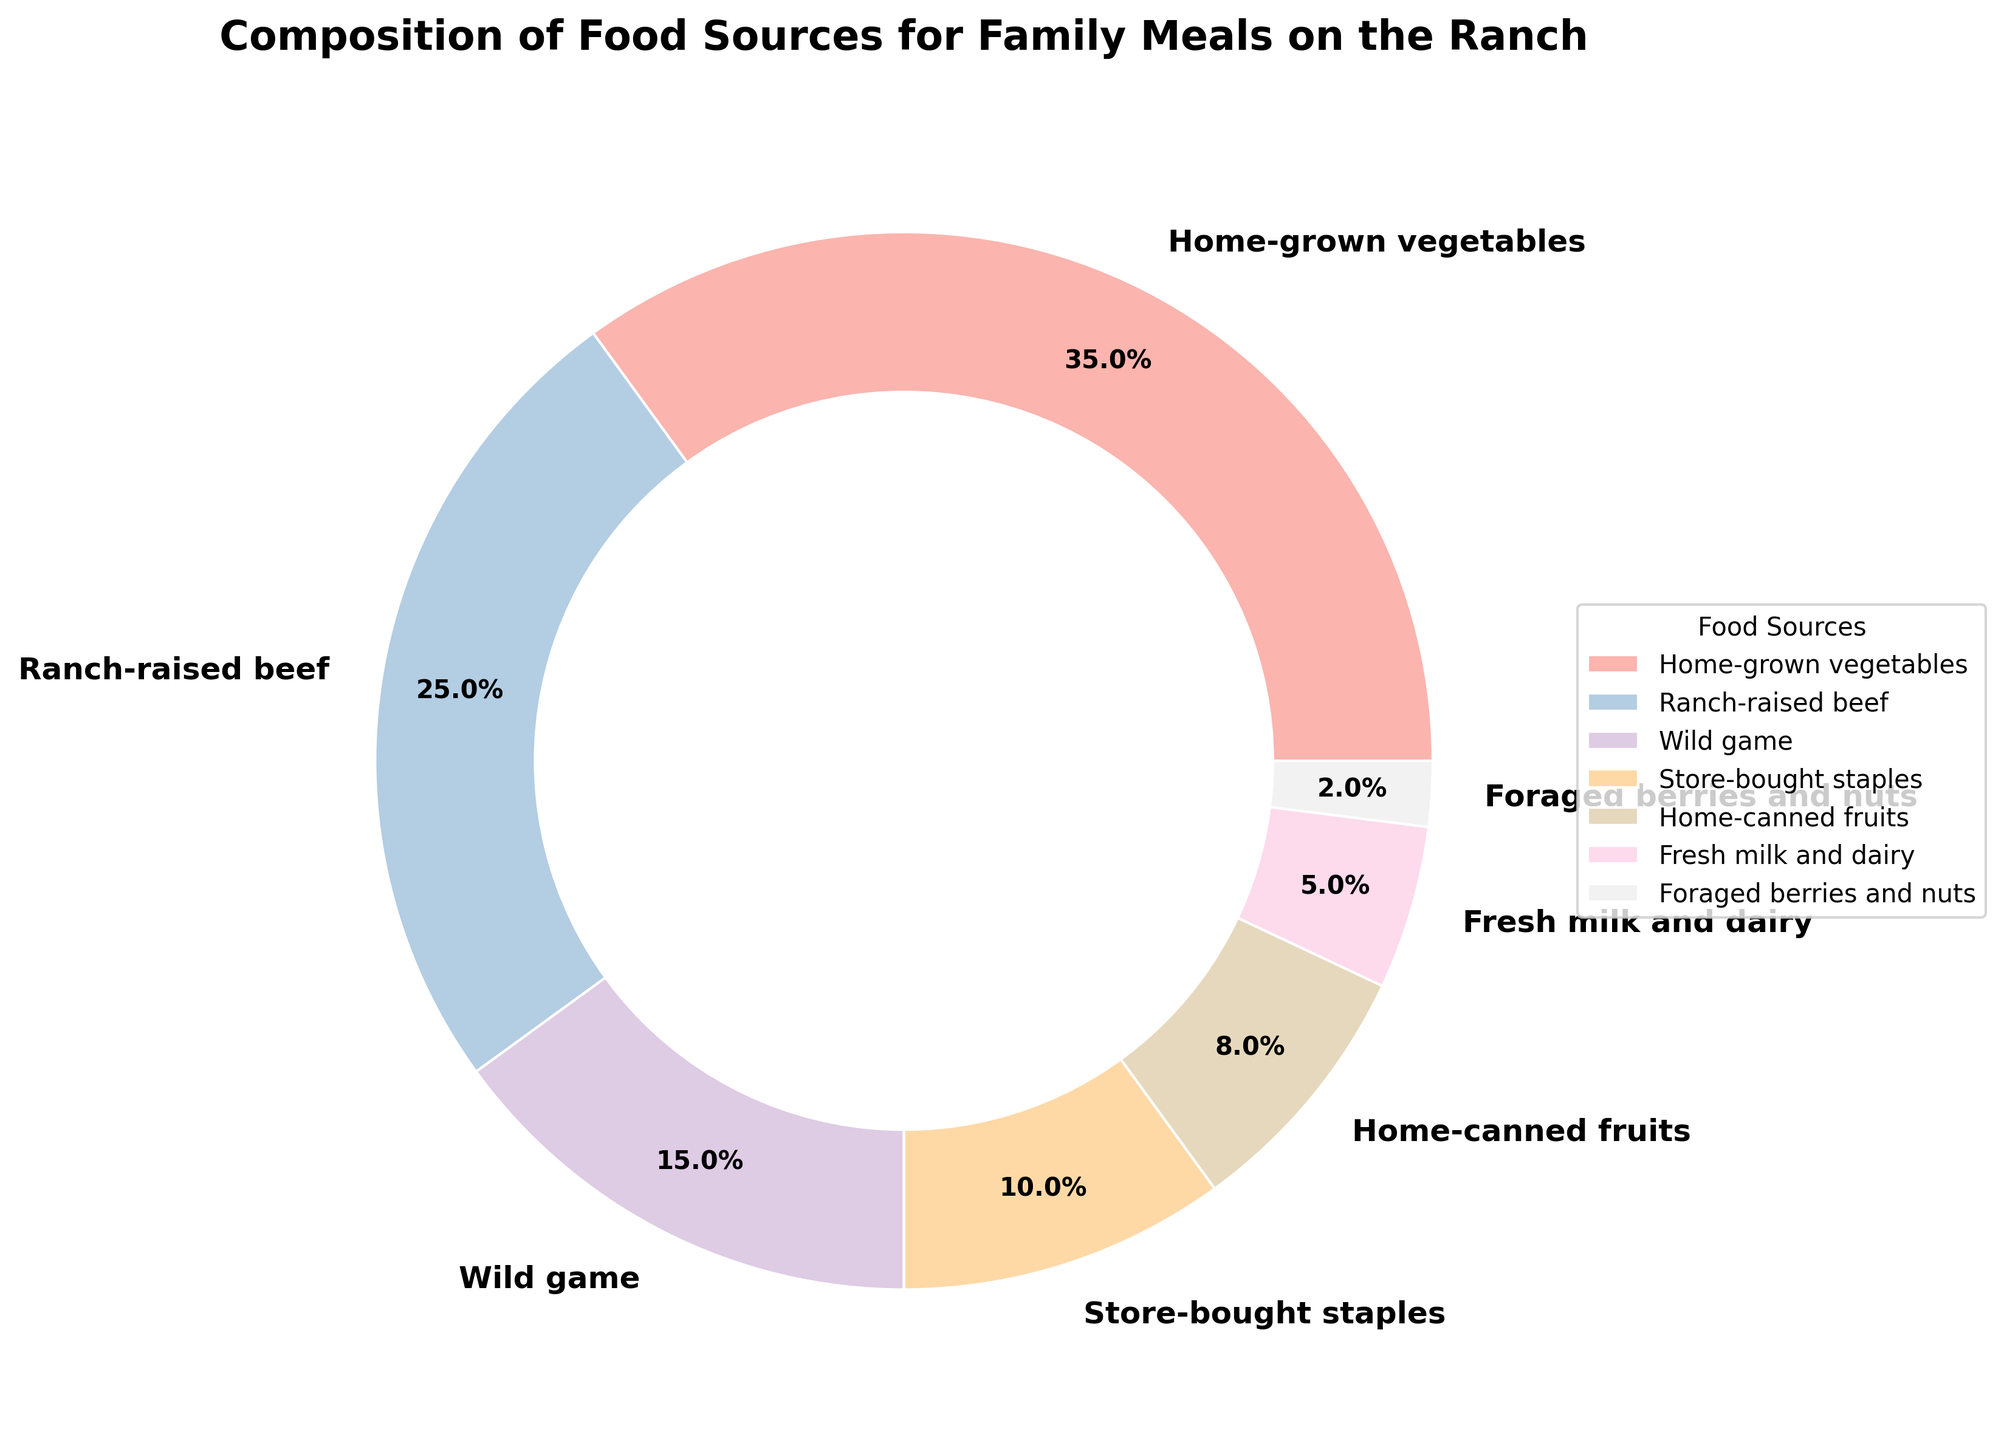Which food source has the highest percentage in the pie chart? The largest section in the pie chart represents "Home-grown vegetables" with 35%. Just by looking at the size of the sections, this is identifiable.
Answer: Home-grown vegetables What is the total percentage of food sources that are home-produced (including home-grown, ranch-raised, home-canned, and fresh milk)? We need to add the percentages for all home-produced sources: Home-grown vegetables (35%), Ranch-raised beef (25%), Home-canned fruits (8%), and Fresh milk and dairy (5%). The total is 35 + 25 + 8 + 5 = 73%.
Answer: 73% How much more is the percentage of "Home-grown vegetables" compared to "Store-bought staples"? We subtract the percentage of "Store-bought staples" from "Home-grown vegetables". So, 35% - 10% = 25%.
Answer: 25% Which food sources combined have the smallest percentage (less than 10%) in the pie chart? We look for food sources with percentages each less than 10%. These are: Foraged berries and nuts (2%), Fresh milk and dairy (5%), and Home-canned fruits (8%).
Answer: Foraged berries and nuts, Fresh milk and dairy, Home-canned fruits What's the average percentage of the top three food sources combined? First, we identify the top three food sources: Home-grown vegetables (35%), Ranch-raised beef (25%), Wild game (15%). Adding these gives 35 + 25 + 15 = 75%. The average is 75/3 = 25%.
Answer: 25% By how many percentage points does the combination of "Ranch-raised beef" and "Wild game" exceed the percentage of "Home-grown vegetables"? First, we add the percentages for Ranch-raised beef (25%) and Wild game (15%), which gives 40%. Then, we subtract the percentage for Home-grown vegetables (35%). So, 40% - 35% = 5%.
Answer: 5% What is the difference in percentage between the least and the most contributing food source? The least contributing is "Foraged berries and nuts" with 2%, and the most contributing is "Home-grown vegetables" with 35%. The difference is 35% - 2% = 33%.
Answer: 33% Between "Ranch-raised beef" and "Wild game", which one contributes less, and by how much percentage? "Ranch-raised beef" has 25%, and "Wild game" has 15%. "Wild game" contributes less, and the difference is 25% - 15% = 10%.
Answer: Wild game, 10% What color represents the "Home-canned fruits" section in the pie chart? Each section in the pie chart is uniquely colored. The "Home-canned fruits" section is one specific color among the pastel shades used. By looking at the visual attributes, it is a specific pastel color.
Answer: pastel color 